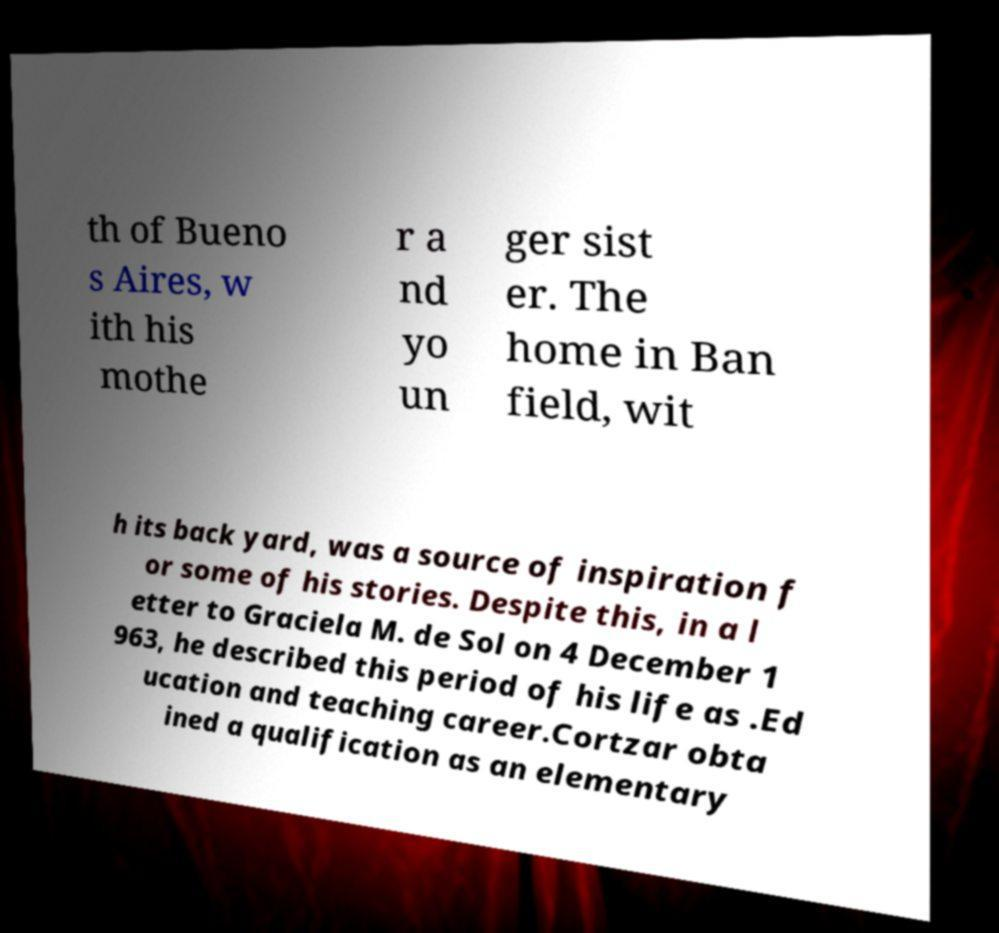There's text embedded in this image that I need extracted. Can you transcribe it verbatim? th of Bueno s Aires, w ith his mothe r a nd yo un ger sist er. The home in Ban field, wit h its back yard, was a source of inspiration f or some of his stories. Despite this, in a l etter to Graciela M. de Sol on 4 December 1 963, he described this period of his life as .Ed ucation and teaching career.Cortzar obta ined a qualification as an elementary 